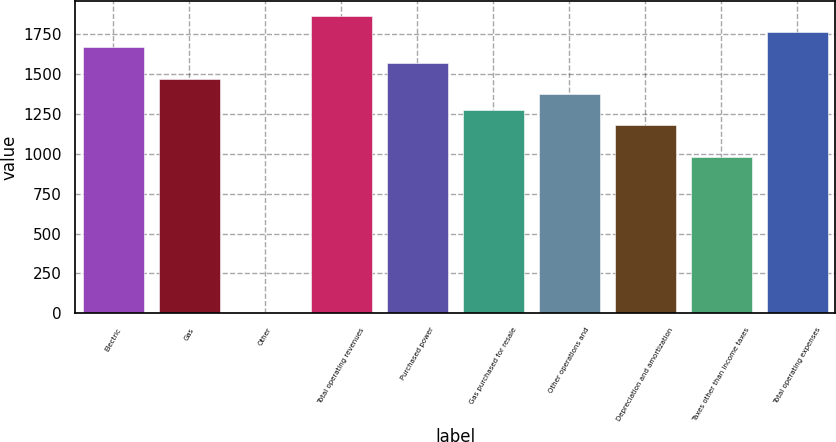<chart> <loc_0><loc_0><loc_500><loc_500><bar_chart><fcel>Electric<fcel>Gas<fcel>Other<fcel>Total operating revenues<fcel>Purchased power<fcel>Gas purchased for resale<fcel>Other operations and<fcel>Depreciation and amortization<fcel>Taxes other than income taxes<fcel>Total operating expenses<nl><fcel>1667.3<fcel>1471.5<fcel>3<fcel>1863.1<fcel>1569.4<fcel>1275.7<fcel>1373.6<fcel>1177.8<fcel>982<fcel>1765.2<nl></chart> 